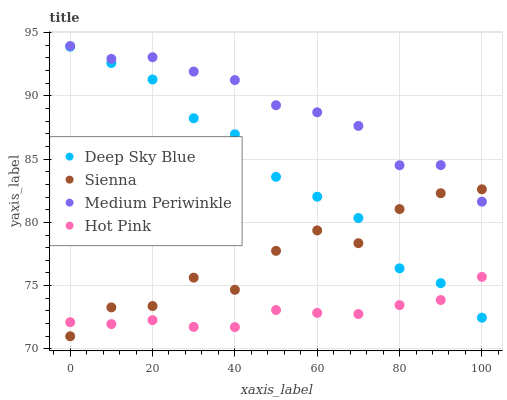Does Hot Pink have the minimum area under the curve?
Answer yes or no. Yes. Does Medium Periwinkle have the maximum area under the curve?
Answer yes or no. Yes. Does Medium Periwinkle have the minimum area under the curve?
Answer yes or no. No. Does Hot Pink have the maximum area under the curve?
Answer yes or no. No. Is Hot Pink the smoothest?
Answer yes or no. Yes. Is Sienna the roughest?
Answer yes or no. Yes. Is Medium Periwinkle the smoothest?
Answer yes or no. No. Is Medium Periwinkle the roughest?
Answer yes or no. No. Does Sienna have the lowest value?
Answer yes or no. Yes. Does Hot Pink have the lowest value?
Answer yes or no. No. Does Medium Periwinkle have the highest value?
Answer yes or no. Yes. Does Hot Pink have the highest value?
Answer yes or no. No. Is Hot Pink less than Medium Periwinkle?
Answer yes or no. Yes. Is Medium Periwinkle greater than Hot Pink?
Answer yes or no. Yes. Does Sienna intersect Medium Periwinkle?
Answer yes or no. Yes. Is Sienna less than Medium Periwinkle?
Answer yes or no. No. Is Sienna greater than Medium Periwinkle?
Answer yes or no. No. Does Hot Pink intersect Medium Periwinkle?
Answer yes or no. No. 